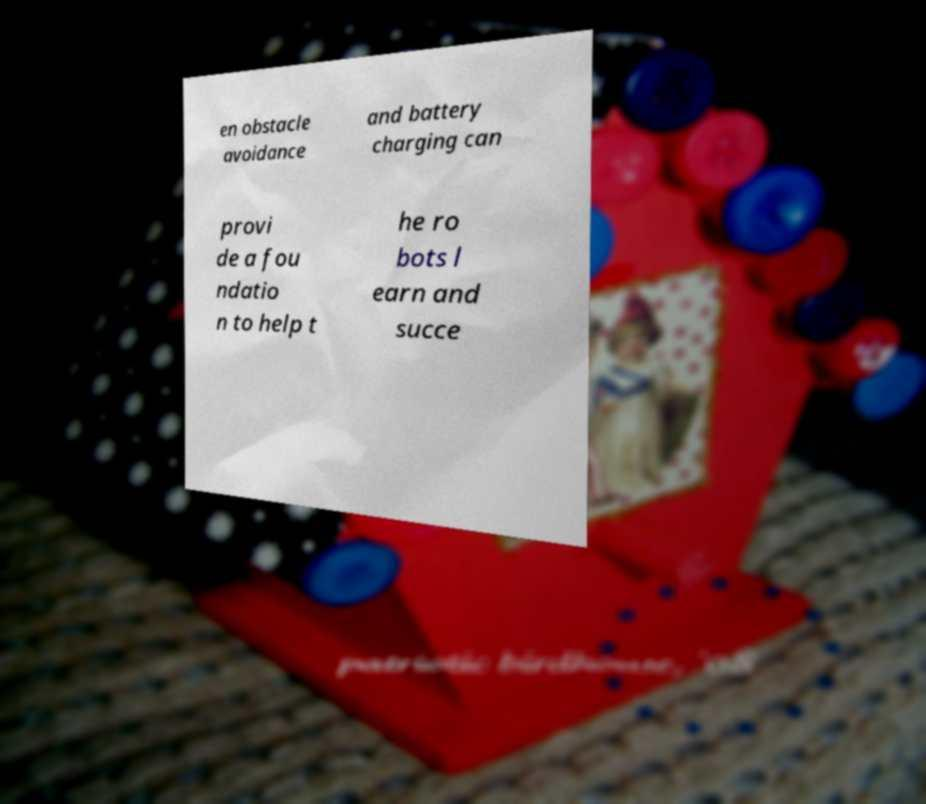Could you assist in decoding the text presented in this image and type it out clearly? en obstacle avoidance and battery charging can provi de a fou ndatio n to help t he ro bots l earn and succe 